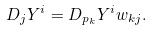<formula> <loc_0><loc_0><loc_500><loc_500>D _ { j } Y ^ { i } = D _ { p _ { k } } Y ^ { i } w _ { k j } .</formula> 